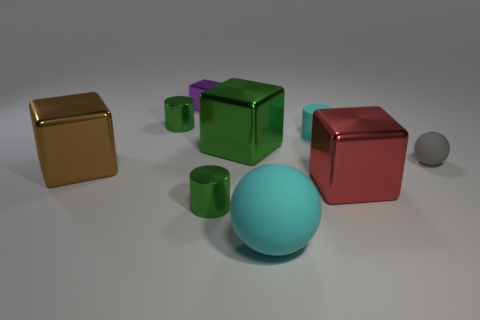How many cyan spheres are on the left side of the large red thing?
Offer a terse response. 1. The brown metal thing that is the same shape as the large green object is what size?
Your response must be concise. Large. What number of brown things are large cubes or large matte cylinders?
Keep it short and to the point. 1. There is a tiny green metallic object behind the large brown block; what number of big cyan things are behind it?
Offer a very short reply. 0. How many other things are there of the same shape as the large red metallic thing?
Provide a succinct answer. 3. What number of big things are the same color as the small matte cylinder?
Ensure brevity in your answer.  1. There is a tiny cube that is made of the same material as the big red block; what is its color?
Make the answer very short. Purple. Is there a cylinder of the same size as the gray sphere?
Your answer should be very brief. Yes. Are there more tiny rubber cylinders that are in front of the big red metallic cube than red objects on the left side of the big brown thing?
Offer a terse response. No. Is the material of the tiny green cylinder that is left of the tiny shiny cube the same as the large brown cube that is in front of the gray object?
Keep it short and to the point. Yes. 